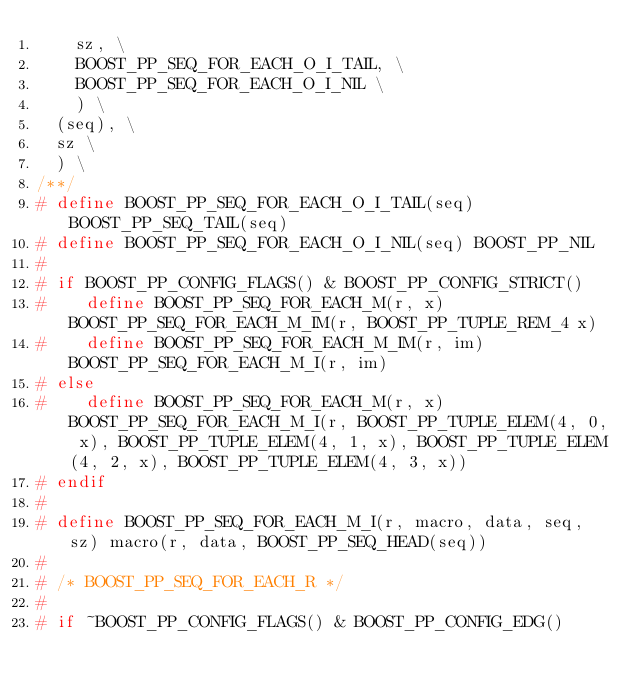Convert code to text. <code><loc_0><loc_0><loc_500><loc_500><_C++_>		sz, \
		BOOST_PP_SEQ_FOR_EACH_O_I_TAIL, \
		BOOST_PP_SEQ_FOR_EACH_O_I_NIL \
		) \
	(seq), \
	sz \
	) \
/**/
# define BOOST_PP_SEQ_FOR_EACH_O_I_TAIL(seq) BOOST_PP_SEQ_TAIL(seq)
# define BOOST_PP_SEQ_FOR_EACH_O_I_NIL(seq) BOOST_PP_NIL
#
# if BOOST_PP_CONFIG_FLAGS() & BOOST_PP_CONFIG_STRICT()
#    define BOOST_PP_SEQ_FOR_EACH_M(r, x) BOOST_PP_SEQ_FOR_EACH_M_IM(r, BOOST_PP_TUPLE_REM_4 x)
#    define BOOST_PP_SEQ_FOR_EACH_M_IM(r, im) BOOST_PP_SEQ_FOR_EACH_M_I(r, im)
# else
#    define BOOST_PP_SEQ_FOR_EACH_M(r, x) BOOST_PP_SEQ_FOR_EACH_M_I(r, BOOST_PP_TUPLE_ELEM(4, 0, x), BOOST_PP_TUPLE_ELEM(4, 1, x), BOOST_PP_TUPLE_ELEM(4, 2, x), BOOST_PP_TUPLE_ELEM(4, 3, x))
# endif
#
# define BOOST_PP_SEQ_FOR_EACH_M_I(r, macro, data, seq, sz) macro(r, data, BOOST_PP_SEQ_HEAD(seq))
#
# /* BOOST_PP_SEQ_FOR_EACH_R */
#
# if ~BOOST_PP_CONFIG_FLAGS() & BOOST_PP_CONFIG_EDG()</code> 